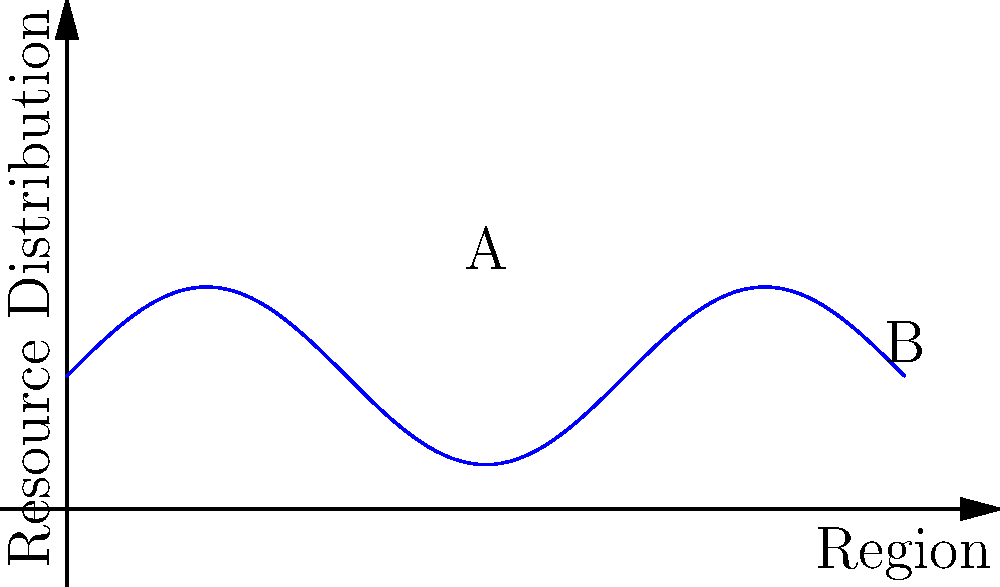The curve shown represents the distribution of humanitarian resources across different regions in Mexico, where the x-axis represents the region and the y-axis represents the resource distribution. If the function describing this curve is $f(x) = 2\sin(x/2) + 3$, calculate the total amount of resources distributed across all regions from A to B. Assume that the distance between A and B is $6\pi$ units. To find the total amount of resources distributed, we need to calculate the area under the curve from A to B. This can be done using a definite integral.

Step 1: Set up the integral
$$\int_0^{6\pi} (2\sin(x/2) + 3) dx$$

Step 2: Integrate the function
For $\int 2\sin(x/2) dx$, use u-substitution with $u = x/2$:
$$\int 2\sin(u) \cdot 2du = -4\cos(u) + C = -4\cos(x/2) + C$$

For $\int 3 dx = 3x + C$

Step 3: Apply the limits
$$[-4\cos(x/2) + 3x]_0^{6\pi}$$

Step 4: Evaluate
$$[-4\cos(3\pi) + 3(6\pi)] - [-4\cos(0) + 3(0)]$$
$$= [4 + 18\pi] - [-4]$$
$$= 4 + 18\pi + 4$$
$$= 18\pi + 8$$

Therefore, the total amount of resources distributed is $18\pi + 8$ units.
Answer: $18\pi + 8$ units 